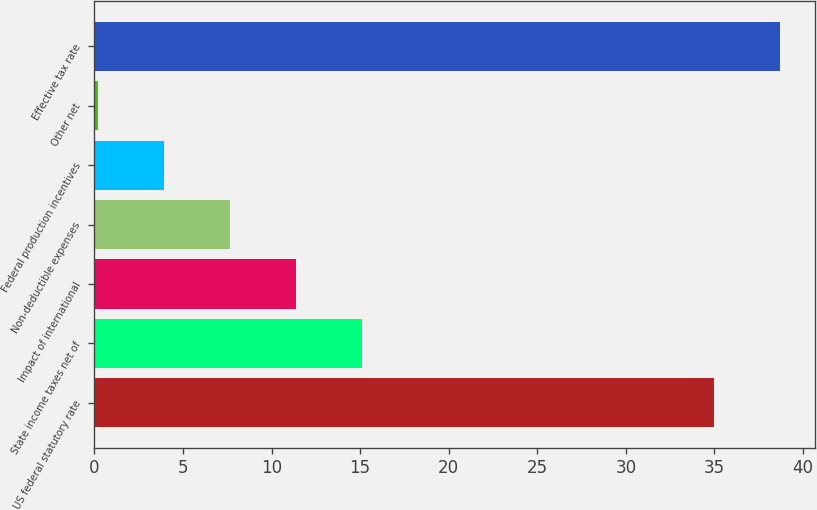Convert chart to OTSL. <chart><loc_0><loc_0><loc_500><loc_500><bar_chart><fcel>US federal statutory rate<fcel>State income taxes net of<fcel>Impact of international<fcel>Non-deductible expenses<fcel>Federal production incentives<fcel>Other net<fcel>Effective tax rate<nl><fcel>35<fcel>15.08<fcel>11.36<fcel>7.64<fcel>3.92<fcel>0.2<fcel>38.72<nl></chart> 